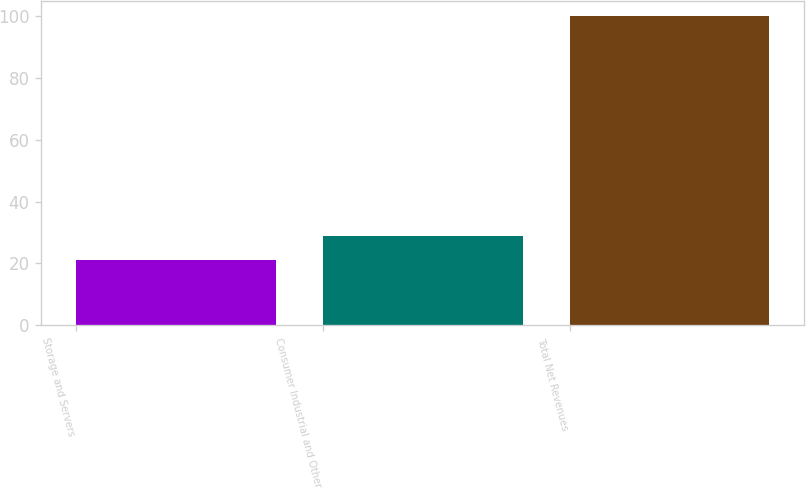<chart> <loc_0><loc_0><loc_500><loc_500><bar_chart><fcel>Storage and Servers<fcel>Consumer Industrial and Other<fcel>Total Net Revenues<nl><fcel>21<fcel>28.9<fcel>100<nl></chart> 